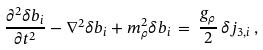<formula> <loc_0><loc_0><loc_500><loc_500>\frac { \partial ^ { 2 } \delta b _ { i } } { \partial t ^ { 2 } } - \nabla ^ { 2 } \delta b _ { i } + m _ { \rho } ^ { 2 } \delta b _ { i } \, = \, \frac { g _ { \rho } } { 2 } \, \delta j _ { 3 , i } \, ,</formula> 